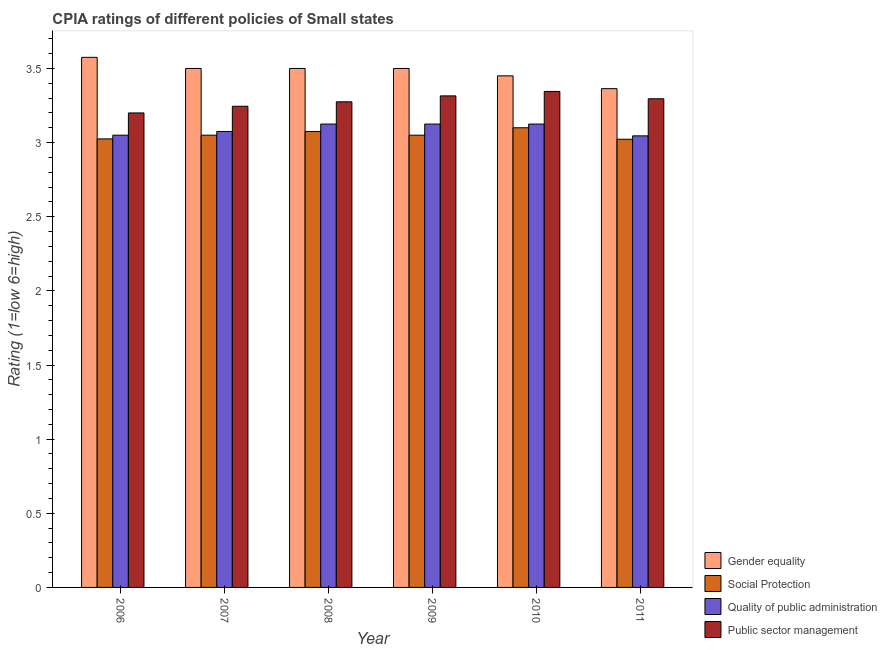How many different coloured bars are there?
Provide a succinct answer. 4. How many groups of bars are there?
Give a very brief answer. 6. Are the number of bars on each tick of the X-axis equal?
Your answer should be very brief. Yes. How many bars are there on the 4th tick from the right?
Provide a succinct answer. 4. What is the cpia rating of social protection in 2010?
Your answer should be very brief. 3.1. Across all years, what is the maximum cpia rating of quality of public administration?
Offer a terse response. 3.12. Across all years, what is the minimum cpia rating of quality of public administration?
Your answer should be very brief. 3.05. In which year was the cpia rating of social protection maximum?
Provide a short and direct response. 2010. What is the total cpia rating of public sector management in the graph?
Keep it short and to the point. 19.68. What is the difference between the cpia rating of gender equality in 2010 and that in 2011?
Your answer should be compact. 0.09. What is the average cpia rating of social protection per year?
Your answer should be compact. 3.05. In the year 2011, what is the difference between the cpia rating of quality of public administration and cpia rating of social protection?
Your answer should be very brief. 0. In how many years, is the cpia rating of gender equality greater than 0.30000000000000004?
Provide a succinct answer. 6. What is the ratio of the cpia rating of public sector management in 2009 to that in 2010?
Offer a very short reply. 0.99. Is the cpia rating of public sector management in 2010 less than that in 2011?
Your answer should be very brief. No. What is the difference between the highest and the second highest cpia rating of public sector management?
Provide a short and direct response. 0.03. What is the difference between the highest and the lowest cpia rating of quality of public administration?
Offer a very short reply. 0.08. What does the 1st bar from the left in 2011 represents?
Ensure brevity in your answer.  Gender equality. What does the 4th bar from the right in 2007 represents?
Your answer should be compact. Gender equality. Is it the case that in every year, the sum of the cpia rating of gender equality and cpia rating of social protection is greater than the cpia rating of quality of public administration?
Offer a terse response. Yes. How many bars are there?
Provide a succinct answer. 24. How many years are there in the graph?
Ensure brevity in your answer.  6. Does the graph contain grids?
Make the answer very short. No. How many legend labels are there?
Your answer should be compact. 4. What is the title of the graph?
Your response must be concise. CPIA ratings of different policies of Small states. Does "Labor Taxes" appear as one of the legend labels in the graph?
Offer a terse response. No. What is the label or title of the X-axis?
Your answer should be compact. Year. What is the Rating (1=low 6=high) in Gender equality in 2006?
Your answer should be very brief. 3.58. What is the Rating (1=low 6=high) of Social Protection in 2006?
Keep it short and to the point. 3.02. What is the Rating (1=low 6=high) of Quality of public administration in 2006?
Your answer should be compact. 3.05. What is the Rating (1=low 6=high) in Public sector management in 2006?
Offer a very short reply. 3.2. What is the Rating (1=low 6=high) in Gender equality in 2007?
Your answer should be compact. 3.5. What is the Rating (1=low 6=high) of Social Protection in 2007?
Provide a short and direct response. 3.05. What is the Rating (1=low 6=high) of Quality of public administration in 2007?
Make the answer very short. 3.08. What is the Rating (1=low 6=high) in Public sector management in 2007?
Make the answer very short. 3.25. What is the Rating (1=low 6=high) of Social Protection in 2008?
Offer a very short reply. 3.08. What is the Rating (1=low 6=high) of Quality of public administration in 2008?
Give a very brief answer. 3.12. What is the Rating (1=low 6=high) in Public sector management in 2008?
Make the answer very short. 3.27. What is the Rating (1=low 6=high) in Social Protection in 2009?
Make the answer very short. 3.05. What is the Rating (1=low 6=high) in Quality of public administration in 2009?
Provide a succinct answer. 3.12. What is the Rating (1=low 6=high) of Public sector management in 2009?
Offer a terse response. 3.31. What is the Rating (1=low 6=high) in Gender equality in 2010?
Give a very brief answer. 3.45. What is the Rating (1=low 6=high) in Quality of public administration in 2010?
Give a very brief answer. 3.12. What is the Rating (1=low 6=high) of Public sector management in 2010?
Give a very brief answer. 3.35. What is the Rating (1=low 6=high) in Gender equality in 2011?
Offer a terse response. 3.36. What is the Rating (1=low 6=high) of Social Protection in 2011?
Ensure brevity in your answer.  3.02. What is the Rating (1=low 6=high) of Quality of public administration in 2011?
Provide a short and direct response. 3.05. What is the Rating (1=low 6=high) in Public sector management in 2011?
Ensure brevity in your answer.  3.3. Across all years, what is the maximum Rating (1=low 6=high) in Gender equality?
Your response must be concise. 3.58. Across all years, what is the maximum Rating (1=low 6=high) in Social Protection?
Ensure brevity in your answer.  3.1. Across all years, what is the maximum Rating (1=low 6=high) of Quality of public administration?
Provide a short and direct response. 3.12. Across all years, what is the maximum Rating (1=low 6=high) in Public sector management?
Make the answer very short. 3.35. Across all years, what is the minimum Rating (1=low 6=high) of Gender equality?
Ensure brevity in your answer.  3.36. Across all years, what is the minimum Rating (1=low 6=high) of Social Protection?
Make the answer very short. 3.02. Across all years, what is the minimum Rating (1=low 6=high) of Quality of public administration?
Provide a succinct answer. 3.05. What is the total Rating (1=low 6=high) of Gender equality in the graph?
Your answer should be very brief. 20.89. What is the total Rating (1=low 6=high) in Social Protection in the graph?
Your answer should be compact. 18.32. What is the total Rating (1=low 6=high) of Quality of public administration in the graph?
Ensure brevity in your answer.  18.55. What is the total Rating (1=low 6=high) in Public sector management in the graph?
Offer a very short reply. 19.68. What is the difference between the Rating (1=low 6=high) in Gender equality in 2006 and that in 2007?
Keep it short and to the point. 0.07. What is the difference between the Rating (1=low 6=high) of Social Protection in 2006 and that in 2007?
Make the answer very short. -0.03. What is the difference between the Rating (1=low 6=high) of Quality of public administration in 2006 and that in 2007?
Keep it short and to the point. -0.03. What is the difference between the Rating (1=low 6=high) in Public sector management in 2006 and that in 2007?
Offer a very short reply. -0.04. What is the difference between the Rating (1=low 6=high) of Gender equality in 2006 and that in 2008?
Your answer should be very brief. 0.07. What is the difference between the Rating (1=low 6=high) in Quality of public administration in 2006 and that in 2008?
Keep it short and to the point. -0.07. What is the difference between the Rating (1=low 6=high) of Public sector management in 2006 and that in 2008?
Make the answer very short. -0.07. What is the difference between the Rating (1=low 6=high) of Gender equality in 2006 and that in 2009?
Your response must be concise. 0.07. What is the difference between the Rating (1=low 6=high) in Social Protection in 2006 and that in 2009?
Offer a terse response. -0.03. What is the difference between the Rating (1=low 6=high) of Quality of public administration in 2006 and that in 2009?
Ensure brevity in your answer.  -0.07. What is the difference between the Rating (1=low 6=high) of Public sector management in 2006 and that in 2009?
Provide a succinct answer. -0.12. What is the difference between the Rating (1=low 6=high) of Gender equality in 2006 and that in 2010?
Make the answer very short. 0.12. What is the difference between the Rating (1=low 6=high) in Social Protection in 2006 and that in 2010?
Your answer should be compact. -0.07. What is the difference between the Rating (1=low 6=high) in Quality of public administration in 2006 and that in 2010?
Provide a short and direct response. -0.07. What is the difference between the Rating (1=low 6=high) of Public sector management in 2006 and that in 2010?
Provide a succinct answer. -0.14. What is the difference between the Rating (1=low 6=high) in Gender equality in 2006 and that in 2011?
Give a very brief answer. 0.21. What is the difference between the Rating (1=low 6=high) in Social Protection in 2006 and that in 2011?
Provide a succinct answer. 0. What is the difference between the Rating (1=low 6=high) of Quality of public administration in 2006 and that in 2011?
Keep it short and to the point. 0. What is the difference between the Rating (1=low 6=high) of Public sector management in 2006 and that in 2011?
Your answer should be compact. -0.1. What is the difference between the Rating (1=low 6=high) in Gender equality in 2007 and that in 2008?
Make the answer very short. 0. What is the difference between the Rating (1=low 6=high) of Social Protection in 2007 and that in 2008?
Provide a succinct answer. -0.03. What is the difference between the Rating (1=low 6=high) in Public sector management in 2007 and that in 2008?
Make the answer very short. -0.03. What is the difference between the Rating (1=low 6=high) in Gender equality in 2007 and that in 2009?
Provide a succinct answer. 0. What is the difference between the Rating (1=low 6=high) in Social Protection in 2007 and that in 2009?
Offer a terse response. 0. What is the difference between the Rating (1=low 6=high) of Public sector management in 2007 and that in 2009?
Give a very brief answer. -0.07. What is the difference between the Rating (1=low 6=high) in Gender equality in 2007 and that in 2010?
Provide a short and direct response. 0.05. What is the difference between the Rating (1=low 6=high) of Social Protection in 2007 and that in 2010?
Keep it short and to the point. -0.05. What is the difference between the Rating (1=low 6=high) of Quality of public administration in 2007 and that in 2010?
Ensure brevity in your answer.  -0.05. What is the difference between the Rating (1=low 6=high) of Public sector management in 2007 and that in 2010?
Provide a succinct answer. -0.1. What is the difference between the Rating (1=low 6=high) in Gender equality in 2007 and that in 2011?
Offer a terse response. 0.14. What is the difference between the Rating (1=low 6=high) in Social Protection in 2007 and that in 2011?
Your answer should be very brief. 0.03. What is the difference between the Rating (1=low 6=high) of Quality of public administration in 2007 and that in 2011?
Ensure brevity in your answer.  0.03. What is the difference between the Rating (1=low 6=high) in Public sector management in 2007 and that in 2011?
Provide a succinct answer. -0.05. What is the difference between the Rating (1=low 6=high) of Social Protection in 2008 and that in 2009?
Your answer should be compact. 0.03. What is the difference between the Rating (1=low 6=high) in Public sector management in 2008 and that in 2009?
Provide a short and direct response. -0.04. What is the difference between the Rating (1=low 6=high) of Social Protection in 2008 and that in 2010?
Your answer should be very brief. -0.03. What is the difference between the Rating (1=low 6=high) of Public sector management in 2008 and that in 2010?
Keep it short and to the point. -0.07. What is the difference between the Rating (1=low 6=high) in Gender equality in 2008 and that in 2011?
Your answer should be compact. 0.14. What is the difference between the Rating (1=low 6=high) in Social Protection in 2008 and that in 2011?
Your answer should be compact. 0.05. What is the difference between the Rating (1=low 6=high) of Quality of public administration in 2008 and that in 2011?
Your response must be concise. 0.08. What is the difference between the Rating (1=low 6=high) in Public sector management in 2008 and that in 2011?
Your response must be concise. -0.02. What is the difference between the Rating (1=low 6=high) in Public sector management in 2009 and that in 2010?
Your answer should be very brief. -0.03. What is the difference between the Rating (1=low 6=high) of Gender equality in 2009 and that in 2011?
Keep it short and to the point. 0.14. What is the difference between the Rating (1=low 6=high) in Social Protection in 2009 and that in 2011?
Offer a very short reply. 0.03. What is the difference between the Rating (1=low 6=high) in Quality of public administration in 2009 and that in 2011?
Your answer should be compact. 0.08. What is the difference between the Rating (1=low 6=high) of Public sector management in 2009 and that in 2011?
Give a very brief answer. 0.02. What is the difference between the Rating (1=low 6=high) in Gender equality in 2010 and that in 2011?
Your answer should be compact. 0.09. What is the difference between the Rating (1=low 6=high) of Social Protection in 2010 and that in 2011?
Provide a succinct answer. 0.08. What is the difference between the Rating (1=low 6=high) in Quality of public administration in 2010 and that in 2011?
Make the answer very short. 0.08. What is the difference between the Rating (1=low 6=high) in Public sector management in 2010 and that in 2011?
Your response must be concise. 0.05. What is the difference between the Rating (1=low 6=high) of Gender equality in 2006 and the Rating (1=low 6=high) of Social Protection in 2007?
Keep it short and to the point. 0.53. What is the difference between the Rating (1=low 6=high) in Gender equality in 2006 and the Rating (1=low 6=high) in Quality of public administration in 2007?
Your answer should be very brief. 0.5. What is the difference between the Rating (1=low 6=high) of Gender equality in 2006 and the Rating (1=low 6=high) of Public sector management in 2007?
Provide a succinct answer. 0.33. What is the difference between the Rating (1=low 6=high) of Social Protection in 2006 and the Rating (1=low 6=high) of Public sector management in 2007?
Your answer should be compact. -0.22. What is the difference between the Rating (1=low 6=high) of Quality of public administration in 2006 and the Rating (1=low 6=high) of Public sector management in 2007?
Ensure brevity in your answer.  -0.2. What is the difference between the Rating (1=low 6=high) in Gender equality in 2006 and the Rating (1=low 6=high) in Quality of public administration in 2008?
Provide a short and direct response. 0.45. What is the difference between the Rating (1=low 6=high) of Gender equality in 2006 and the Rating (1=low 6=high) of Public sector management in 2008?
Provide a succinct answer. 0.3. What is the difference between the Rating (1=low 6=high) of Quality of public administration in 2006 and the Rating (1=low 6=high) of Public sector management in 2008?
Ensure brevity in your answer.  -0.23. What is the difference between the Rating (1=low 6=high) in Gender equality in 2006 and the Rating (1=low 6=high) in Social Protection in 2009?
Provide a short and direct response. 0.53. What is the difference between the Rating (1=low 6=high) in Gender equality in 2006 and the Rating (1=low 6=high) in Quality of public administration in 2009?
Make the answer very short. 0.45. What is the difference between the Rating (1=low 6=high) in Gender equality in 2006 and the Rating (1=low 6=high) in Public sector management in 2009?
Offer a very short reply. 0.26. What is the difference between the Rating (1=low 6=high) of Social Protection in 2006 and the Rating (1=low 6=high) of Public sector management in 2009?
Give a very brief answer. -0.29. What is the difference between the Rating (1=low 6=high) in Quality of public administration in 2006 and the Rating (1=low 6=high) in Public sector management in 2009?
Your response must be concise. -0.27. What is the difference between the Rating (1=low 6=high) of Gender equality in 2006 and the Rating (1=low 6=high) of Social Protection in 2010?
Your answer should be compact. 0.47. What is the difference between the Rating (1=low 6=high) of Gender equality in 2006 and the Rating (1=low 6=high) of Quality of public administration in 2010?
Your response must be concise. 0.45. What is the difference between the Rating (1=low 6=high) in Gender equality in 2006 and the Rating (1=low 6=high) in Public sector management in 2010?
Provide a short and direct response. 0.23. What is the difference between the Rating (1=low 6=high) of Social Protection in 2006 and the Rating (1=low 6=high) of Public sector management in 2010?
Your response must be concise. -0.32. What is the difference between the Rating (1=low 6=high) of Quality of public administration in 2006 and the Rating (1=low 6=high) of Public sector management in 2010?
Make the answer very short. -0.29. What is the difference between the Rating (1=low 6=high) in Gender equality in 2006 and the Rating (1=low 6=high) in Social Protection in 2011?
Give a very brief answer. 0.55. What is the difference between the Rating (1=low 6=high) in Gender equality in 2006 and the Rating (1=low 6=high) in Quality of public administration in 2011?
Your response must be concise. 0.53. What is the difference between the Rating (1=low 6=high) in Gender equality in 2006 and the Rating (1=low 6=high) in Public sector management in 2011?
Offer a very short reply. 0.28. What is the difference between the Rating (1=low 6=high) in Social Protection in 2006 and the Rating (1=low 6=high) in Quality of public administration in 2011?
Give a very brief answer. -0.02. What is the difference between the Rating (1=low 6=high) in Social Protection in 2006 and the Rating (1=low 6=high) in Public sector management in 2011?
Your response must be concise. -0.27. What is the difference between the Rating (1=low 6=high) of Quality of public administration in 2006 and the Rating (1=low 6=high) of Public sector management in 2011?
Give a very brief answer. -0.25. What is the difference between the Rating (1=low 6=high) of Gender equality in 2007 and the Rating (1=low 6=high) of Social Protection in 2008?
Offer a very short reply. 0.42. What is the difference between the Rating (1=low 6=high) of Gender equality in 2007 and the Rating (1=low 6=high) of Quality of public administration in 2008?
Your response must be concise. 0.38. What is the difference between the Rating (1=low 6=high) of Gender equality in 2007 and the Rating (1=low 6=high) of Public sector management in 2008?
Offer a very short reply. 0.23. What is the difference between the Rating (1=low 6=high) in Social Protection in 2007 and the Rating (1=low 6=high) in Quality of public administration in 2008?
Provide a succinct answer. -0.07. What is the difference between the Rating (1=low 6=high) in Social Protection in 2007 and the Rating (1=low 6=high) in Public sector management in 2008?
Give a very brief answer. -0.23. What is the difference between the Rating (1=low 6=high) of Gender equality in 2007 and the Rating (1=low 6=high) of Social Protection in 2009?
Provide a succinct answer. 0.45. What is the difference between the Rating (1=low 6=high) of Gender equality in 2007 and the Rating (1=low 6=high) of Quality of public administration in 2009?
Keep it short and to the point. 0.38. What is the difference between the Rating (1=low 6=high) of Gender equality in 2007 and the Rating (1=low 6=high) of Public sector management in 2009?
Keep it short and to the point. 0.18. What is the difference between the Rating (1=low 6=high) in Social Protection in 2007 and the Rating (1=low 6=high) in Quality of public administration in 2009?
Your response must be concise. -0.07. What is the difference between the Rating (1=low 6=high) in Social Protection in 2007 and the Rating (1=low 6=high) in Public sector management in 2009?
Keep it short and to the point. -0.27. What is the difference between the Rating (1=low 6=high) of Quality of public administration in 2007 and the Rating (1=low 6=high) of Public sector management in 2009?
Keep it short and to the point. -0.24. What is the difference between the Rating (1=low 6=high) of Gender equality in 2007 and the Rating (1=low 6=high) of Social Protection in 2010?
Make the answer very short. 0.4. What is the difference between the Rating (1=low 6=high) of Gender equality in 2007 and the Rating (1=low 6=high) of Public sector management in 2010?
Provide a short and direct response. 0.15. What is the difference between the Rating (1=low 6=high) of Social Protection in 2007 and the Rating (1=low 6=high) of Quality of public administration in 2010?
Offer a terse response. -0.07. What is the difference between the Rating (1=low 6=high) in Social Protection in 2007 and the Rating (1=low 6=high) in Public sector management in 2010?
Give a very brief answer. -0.29. What is the difference between the Rating (1=low 6=high) in Quality of public administration in 2007 and the Rating (1=low 6=high) in Public sector management in 2010?
Ensure brevity in your answer.  -0.27. What is the difference between the Rating (1=low 6=high) of Gender equality in 2007 and the Rating (1=low 6=high) of Social Protection in 2011?
Make the answer very short. 0.48. What is the difference between the Rating (1=low 6=high) of Gender equality in 2007 and the Rating (1=low 6=high) of Quality of public administration in 2011?
Ensure brevity in your answer.  0.45. What is the difference between the Rating (1=low 6=high) in Gender equality in 2007 and the Rating (1=low 6=high) in Public sector management in 2011?
Provide a short and direct response. 0.2. What is the difference between the Rating (1=low 6=high) in Social Protection in 2007 and the Rating (1=low 6=high) in Quality of public administration in 2011?
Offer a terse response. 0. What is the difference between the Rating (1=low 6=high) of Social Protection in 2007 and the Rating (1=low 6=high) of Public sector management in 2011?
Your answer should be compact. -0.25. What is the difference between the Rating (1=low 6=high) in Quality of public administration in 2007 and the Rating (1=low 6=high) in Public sector management in 2011?
Keep it short and to the point. -0.22. What is the difference between the Rating (1=low 6=high) of Gender equality in 2008 and the Rating (1=low 6=high) of Social Protection in 2009?
Provide a short and direct response. 0.45. What is the difference between the Rating (1=low 6=high) in Gender equality in 2008 and the Rating (1=low 6=high) in Public sector management in 2009?
Your answer should be very brief. 0.18. What is the difference between the Rating (1=low 6=high) of Social Protection in 2008 and the Rating (1=low 6=high) of Quality of public administration in 2009?
Your answer should be very brief. -0.05. What is the difference between the Rating (1=low 6=high) of Social Protection in 2008 and the Rating (1=low 6=high) of Public sector management in 2009?
Your answer should be very brief. -0.24. What is the difference between the Rating (1=low 6=high) in Quality of public administration in 2008 and the Rating (1=low 6=high) in Public sector management in 2009?
Ensure brevity in your answer.  -0.19. What is the difference between the Rating (1=low 6=high) in Gender equality in 2008 and the Rating (1=low 6=high) in Social Protection in 2010?
Offer a very short reply. 0.4. What is the difference between the Rating (1=low 6=high) of Gender equality in 2008 and the Rating (1=low 6=high) of Quality of public administration in 2010?
Make the answer very short. 0.38. What is the difference between the Rating (1=low 6=high) in Gender equality in 2008 and the Rating (1=low 6=high) in Public sector management in 2010?
Offer a terse response. 0.15. What is the difference between the Rating (1=low 6=high) of Social Protection in 2008 and the Rating (1=low 6=high) of Public sector management in 2010?
Your answer should be compact. -0.27. What is the difference between the Rating (1=low 6=high) in Quality of public administration in 2008 and the Rating (1=low 6=high) in Public sector management in 2010?
Your answer should be very brief. -0.22. What is the difference between the Rating (1=low 6=high) of Gender equality in 2008 and the Rating (1=low 6=high) of Social Protection in 2011?
Your answer should be compact. 0.48. What is the difference between the Rating (1=low 6=high) in Gender equality in 2008 and the Rating (1=low 6=high) in Quality of public administration in 2011?
Ensure brevity in your answer.  0.45. What is the difference between the Rating (1=low 6=high) of Gender equality in 2008 and the Rating (1=low 6=high) of Public sector management in 2011?
Your response must be concise. 0.2. What is the difference between the Rating (1=low 6=high) in Social Protection in 2008 and the Rating (1=low 6=high) in Quality of public administration in 2011?
Give a very brief answer. 0.03. What is the difference between the Rating (1=low 6=high) in Social Protection in 2008 and the Rating (1=low 6=high) in Public sector management in 2011?
Your answer should be compact. -0.22. What is the difference between the Rating (1=low 6=high) in Quality of public administration in 2008 and the Rating (1=low 6=high) in Public sector management in 2011?
Give a very brief answer. -0.17. What is the difference between the Rating (1=low 6=high) of Gender equality in 2009 and the Rating (1=low 6=high) of Social Protection in 2010?
Keep it short and to the point. 0.4. What is the difference between the Rating (1=low 6=high) of Gender equality in 2009 and the Rating (1=low 6=high) of Quality of public administration in 2010?
Offer a very short reply. 0.38. What is the difference between the Rating (1=low 6=high) of Gender equality in 2009 and the Rating (1=low 6=high) of Public sector management in 2010?
Keep it short and to the point. 0.15. What is the difference between the Rating (1=low 6=high) of Social Protection in 2009 and the Rating (1=low 6=high) of Quality of public administration in 2010?
Offer a terse response. -0.07. What is the difference between the Rating (1=low 6=high) in Social Protection in 2009 and the Rating (1=low 6=high) in Public sector management in 2010?
Offer a very short reply. -0.29. What is the difference between the Rating (1=low 6=high) in Quality of public administration in 2009 and the Rating (1=low 6=high) in Public sector management in 2010?
Give a very brief answer. -0.22. What is the difference between the Rating (1=low 6=high) of Gender equality in 2009 and the Rating (1=low 6=high) of Social Protection in 2011?
Offer a terse response. 0.48. What is the difference between the Rating (1=low 6=high) in Gender equality in 2009 and the Rating (1=low 6=high) in Quality of public administration in 2011?
Your response must be concise. 0.45. What is the difference between the Rating (1=low 6=high) of Gender equality in 2009 and the Rating (1=low 6=high) of Public sector management in 2011?
Offer a terse response. 0.2. What is the difference between the Rating (1=low 6=high) of Social Protection in 2009 and the Rating (1=low 6=high) of Quality of public administration in 2011?
Offer a terse response. 0. What is the difference between the Rating (1=low 6=high) of Social Protection in 2009 and the Rating (1=low 6=high) of Public sector management in 2011?
Your answer should be compact. -0.25. What is the difference between the Rating (1=low 6=high) of Quality of public administration in 2009 and the Rating (1=low 6=high) of Public sector management in 2011?
Your answer should be compact. -0.17. What is the difference between the Rating (1=low 6=high) in Gender equality in 2010 and the Rating (1=low 6=high) in Social Protection in 2011?
Your answer should be very brief. 0.43. What is the difference between the Rating (1=low 6=high) in Gender equality in 2010 and the Rating (1=low 6=high) in Quality of public administration in 2011?
Offer a terse response. 0.4. What is the difference between the Rating (1=low 6=high) in Gender equality in 2010 and the Rating (1=low 6=high) in Public sector management in 2011?
Keep it short and to the point. 0.15. What is the difference between the Rating (1=low 6=high) in Social Protection in 2010 and the Rating (1=low 6=high) in Quality of public administration in 2011?
Your answer should be very brief. 0.05. What is the difference between the Rating (1=low 6=high) in Social Protection in 2010 and the Rating (1=low 6=high) in Public sector management in 2011?
Provide a short and direct response. -0.2. What is the difference between the Rating (1=low 6=high) of Quality of public administration in 2010 and the Rating (1=low 6=high) of Public sector management in 2011?
Your answer should be very brief. -0.17. What is the average Rating (1=low 6=high) of Gender equality per year?
Make the answer very short. 3.48. What is the average Rating (1=low 6=high) of Social Protection per year?
Your answer should be very brief. 3.05. What is the average Rating (1=low 6=high) in Quality of public administration per year?
Offer a very short reply. 3.09. What is the average Rating (1=low 6=high) in Public sector management per year?
Your response must be concise. 3.28. In the year 2006, what is the difference between the Rating (1=low 6=high) in Gender equality and Rating (1=low 6=high) in Social Protection?
Keep it short and to the point. 0.55. In the year 2006, what is the difference between the Rating (1=low 6=high) of Gender equality and Rating (1=low 6=high) of Quality of public administration?
Provide a short and direct response. 0.53. In the year 2006, what is the difference between the Rating (1=low 6=high) in Gender equality and Rating (1=low 6=high) in Public sector management?
Your answer should be compact. 0.38. In the year 2006, what is the difference between the Rating (1=low 6=high) of Social Protection and Rating (1=low 6=high) of Quality of public administration?
Keep it short and to the point. -0.03. In the year 2006, what is the difference between the Rating (1=low 6=high) in Social Protection and Rating (1=low 6=high) in Public sector management?
Make the answer very short. -0.17. In the year 2006, what is the difference between the Rating (1=low 6=high) in Quality of public administration and Rating (1=low 6=high) in Public sector management?
Give a very brief answer. -0.15. In the year 2007, what is the difference between the Rating (1=low 6=high) in Gender equality and Rating (1=low 6=high) in Social Protection?
Offer a very short reply. 0.45. In the year 2007, what is the difference between the Rating (1=low 6=high) in Gender equality and Rating (1=low 6=high) in Quality of public administration?
Provide a short and direct response. 0.42. In the year 2007, what is the difference between the Rating (1=low 6=high) of Gender equality and Rating (1=low 6=high) of Public sector management?
Your answer should be compact. 0.26. In the year 2007, what is the difference between the Rating (1=low 6=high) in Social Protection and Rating (1=low 6=high) in Quality of public administration?
Your answer should be compact. -0.03. In the year 2007, what is the difference between the Rating (1=low 6=high) in Social Protection and Rating (1=low 6=high) in Public sector management?
Give a very brief answer. -0.2. In the year 2007, what is the difference between the Rating (1=low 6=high) in Quality of public administration and Rating (1=low 6=high) in Public sector management?
Offer a very short reply. -0.17. In the year 2008, what is the difference between the Rating (1=low 6=high) in Gender equality and Rating (1=low 6=high) in Social Protection?
Your response must be concise. 0.42. In the year 2008, what is the difference between the Rating (1=low 6=high) in Gender equality and Rating (1=low 6=high) in Quality of public administration?
Make the answer very short. 0.38. In the year 2008, what is the difference between the Rating (1=low 6=high) of Gender equality and Rating (1=low 6=high) of Public sector management?
Provide a short and direct response. 0.23. In the year 2009, what is the difference between the Rating (1=low 6=high) of Gender equality and Rating (1=low 6=high) of Social Protection?
Ensure brevity in your answer.  0.45. In the year 2009, what is the difference between the Rating (1=low 6=high) of Gender equality and Rating (1=low 6=high) of Public sector management?
Your answer should be compact. 0.18. In the year 2009, what is the difference between the Rating (1=low 6=high) in Social Protection and Rating (1=low 6=high) in Quality of public administration?
Give a very brief answer. -0.07. In the year 2009, what is the difference between the Rating (1=low 6=high) of Social Protection and Rating (1=low 6=high) of Public sector management?
Ensure brevity in your answer.  -0.27. In the year 2009, what is the difference between the Rating (1=low 6=high) of Quality of public administration and Rating (1=low 6=high) of Public sector management?
Give a very brief answer. -0.19. In the year 2010, what is the difference between the Rating (1=low 6=high) in Gender equality and Rating (1=low 6=high) in Social Protection?
Make the answer very short. 0.35. In the year 2010, what is the difference between the Rating (1=low 6=high) of Gender equality and Rating (1=low 6=high) of Quality of public administration?
Ensure brevity in your answer.  0.33. In the year 2010, what is the difference between the Rating (1=low 6=high) in Gender equality and Rating (1=low 6=high) in Public sector management?
Your response must be concise. 0.1. In the year 2010, what is the difference between the Rating (1=low 6=high) in Social Protection and Rating (1=low 6=high) in Quality of public administration?
Your answer should be very brief. -0.03. In the year 2010, what is the difference between the Rating (1=low 6=high) of Social Protection and Rating (1=low 6=high) of Public sector management?
Give a very brief answer. -0.24. In the year 2010, what is the difference between the Rating (1=low 6=high) of Quality of public administration and Rating (1=low 6=high) of Public sector management?
Ensure brevity in your answer.  -0.22. In the year 2011, what is the difference between the Rating (1=low 6=high) in Gender equality and Rating (1=low 6=high) in Social Protection?
Ensure brevity in your answer.  0.34. In the year 2011, what is the difference between the Rating (1=low 6=high) of Gender equality and Rating (1=low 6=high) of Quality of public administration?
Give a very brief answer. 0.32. In the year 2011, what is the difference between the Rating (1=low 6=high) of Gender equality and Rating (1=low 6=high) of Public sector management?
Your answer should be compact. 0.07. In the year 2011, what is the difference between the Rating (1=low 6=high) in Social Protection and Rating (1=low 6=high) in Quality of public administration?
Offer a very short reply. -0.02. In the year 2011, what is the difference between the Rating (1=low 6=high) in Social Protection and Rating (1=low 6=high) in Public sector management?
Your answer should be compact. -0.27. In the year 2011, what is the difference between the Rating (1=low 6=high) of Quality of public administration and Rating (1=low 6=high) of Public sector management?
Ensure brevity in your answer.  -0.25. What is the ratio of the Rating (1=low 6=high) in Gender equality in 2006 to that in 2007?
Offer a terse response. 1.02. What is the ratio of the Rating (1=low 6=high) in Public sector management in 2006 to that in 2007?
Ensure brevity in your answer.  0.99. What is the ratio of the Rating (1=low 6=high) of Gender equality in 2006 to that in 2008?
Offer a terse response. 1.02. What is the ratio of the Rating (1=low 6=high) in Social Protection in 2006 to that in 2008?
Give a very brief answer. 0.98. What is the ratio of the Rating (1=low 6=high) in Quality of public administration in 2006 to that in 2008?
Give a very brief answer. 0.98. What is the ratio of the Rating (1=low 6=high) in Public sector management in 2006 to that in 2008?
Offer a very short reply. 0.98. What is the ratio of the Rating (1=low 6=high) of Gender equality in 2006 to that in 2009?
Your response must be concise. 1.02. What is the ratio of the Rating (1=low 6=high) in Social Protection in 2006 to that in 2009?
Provide a short and direct response. 0.99. What is the ratio of the Rating (1=low 6=high) in Public sector management in 2006 to that in 2009?
Give a very brief answer. 0.97. What is the ratio of the Rating (1=low 6=high) of Gender equality in 2006 to that in 2010?
Your answer should be very brief. 1.04. What is the ratio of the Rating (1=low 6=high) in Social Protection in 2006 to that in 2010?
Make the answer very short. 0.98. What is the ratio of the Rating (1=low 6=high) in Public sector management in 2006 to that in 2010?
Provide a succinct answer. 0.96. What is the ratio of the Rating (1=low 6=high) of Gender equality in 2006 to that in 2011?
Give a very brief answer. 1.06. What is the ratio of the Rating (1=low 6=high) of Quality of public administration in 2006 to that in 2011?
Provide a short and direct response. 1. What is the ratio of the Rating (1=low 6=high) in Public sector management in 2006 to that in 2011?
Offer a very short reply. 0.97. What is the ratio of the Rating (1=low 6=high) in Gender equality in 2007 to that in 2009?
Your answer should be compact. 1. What is the ratio of the Rating (1=low 6=high) of Social Protection in 2007 to that in 2009?
Give a very brief answer. 1. What is the ratio of the Rating (1=low 6=high) in Quality of public administration in 2007 to that in 2009?
Offer a terse response. 0.98. What is the ratio of the Rating (1=low 6=high) of Public sector management in 2007 to that in 2009?
Make the answer very short. 0.98. What is the ratio of the Rating (1=low 6=high) in Gender equality in 2007 to that in 2010?
Your answer should be very brief. 1.01. What is the ratio of the Rating (1=low 6=high) in Social Protection in 2007 to that in 2010?
Ensure brevity in your answer.  0.98. What is the ratio of the Rating (1=low 6=high) in Quality of public administration in 2007 to that in 2010?
Provide a succinct answer. 0.98. What is the ratio of the Rating (1=low 6=high) in Public sector management in 2007 to that in 2010?
Your answer should be compact. 0.97. What is the ratio of the Rating (1=low 6=high) in Gender equality in 2007 to that in 2011?
Keep it short and to the point. 1.04. What is the ratio of the Rating (1=low 6=high) in Social Protection in 2007 to that in 2011?
Ensure brevity in your answer.  1.01. What is the ratio of the Rating (1=low 6=high) of Quality of public administration in 2007 to that in 2011?
Offer a terse response. 1.01. What is the ratio of the Rating (1=low 6=high) in Public sector management in 2007 to that in 2011?
Offer a terse response. 0.98. What is the ratio of the Rating (1=low 6=high) of Gender equality in 2008 to that in 2009?
Provide a short and direct response. 1. What is the ratio of the Rating (1=low 6=high) of Social Protection in 2008 to that in 2009?
Keep it short and to the point. 1.01. What is the ratio of the Rating (1=low 6=high) in Quality of public administration in 2008 to that in 2009?
Give a very brief answer. 1. What is the ratio of the Rating (1=low 6=high) of Public sector management in 2008 to that in 2009?
Provide a short and direct response. 0.99. What is the ratio of the Rating (1=low 6=high) of Gender equality in 2008 to that in 2010?
Give a very brief answer. 1.01. What is the ratio of the Rating (1=low 6=high) of Social Protection in 2008 to that in 2010?
Offer a very short reply. 0.99. What is the ratio of the Rating (1=low 6=high) in Public sector management in 2008 to that in 2010?
Offer a very short reply. 0.98. What is the ratio of the Rating (1=low 6=high) in Gender equality in 2008 to that in 2011?
Your answer should be very brief. 1.04. What is the ratio of the Rating (1=low 6=high) of Social Protection in 2008 to that in 2011?
Provide a short and direct response. 1.02. What is the ratio of the Rating (1=low 6=high) in Quality of public administration in 2008 to that in 2011?
Provide a short and direct response. 1.03. What is the ratio of the Rating (1=low 6=high) in Gender equality in 2009 to that in 2010?
Keep it short and to the point. 1.01. What is the ratio of the Rating (1=low 6=high) of Social Protection in 2009 to that in 2010?
Offer a very short reply. 0.98. What is the ratio of the Rating (1=low 6=high) of Quality of public administration in 2009 to that in 2010?
Make the answer very short. 1. What is the ratio of the Rating (1=low 6=high) in Public sector management in 2009 to that in 2010?
Your answer should be compact. 0.99. What is the ratio of the Rating (1=low 6=high) in Gender equality in 2009 to that in 2011?
Provide a short and direct response. 1.04. What is the ratio of the Rating (1=low 6=high) of Social Protection in 2009 to that in 2011?
Your response must be concise. 1.01. What is the ratio of the Rating (1=low 6=high) in Quality of public administration in 2009 to that in 2011?
Your response must be concise. 1.03. What is the ratio of the Rating (1=low 6=high) of Public sector management in 2009 to that in 2011?
Offer a terse response. 1.01. What is the ratio of the Rating (1=low 6=high) in Gender equality in 2010 to that in 2011?
Offer a very short reply. 1.03. What is the ratio of the Rating (1=low 6=high) of Social Protection in 2010 to that in 2011?
Offer a terse response. 1.03. What is the ratio of the Rating (1=low 6=high) of Quality of public administration in 2010 to that in 2011?
Your answer should be compact. 1.03. What is the ratio of the Rating (1=low 6=high) of Public sector management in 2010 to that in 2011?
Offer a very short reply. 1.01. What is the difference between the highest and the second highest Rating (1=low 6=high) of Gender equality?
Provide a succinct answer. 0.07. What is the difference between the highest and the second highest Rating (1=low 6=high) of Social Protection?
Keep it short and to the point. 0.03. What is the difference between the highest and the second highest Rating (1=low 6=high) of Quality of public administration?
Give a very brief answer. 0. What is the difference between the highest and the second highest Rating (1=low 6=high) in Public sector management?
Provide a short and direct response. 0.03. What is the difference between the highest and the lowest Rating (1=low 6=high) in Gender equality?
Give a very brief answer. 0.21. What is the difference between the highest and the lowest Rating (1=low 6=high) in Social Protection?
Your response must be concise. 0.08. What is the difference between the highest and the lowest Rating (1=low 6=high) of Quality of public administration?
Your answer should be very brief. 0.08. What is the difference between the highest and the lowest Rating (1=low 6=high) of Public sector management?
Keep it short and to the point. 0.14. 